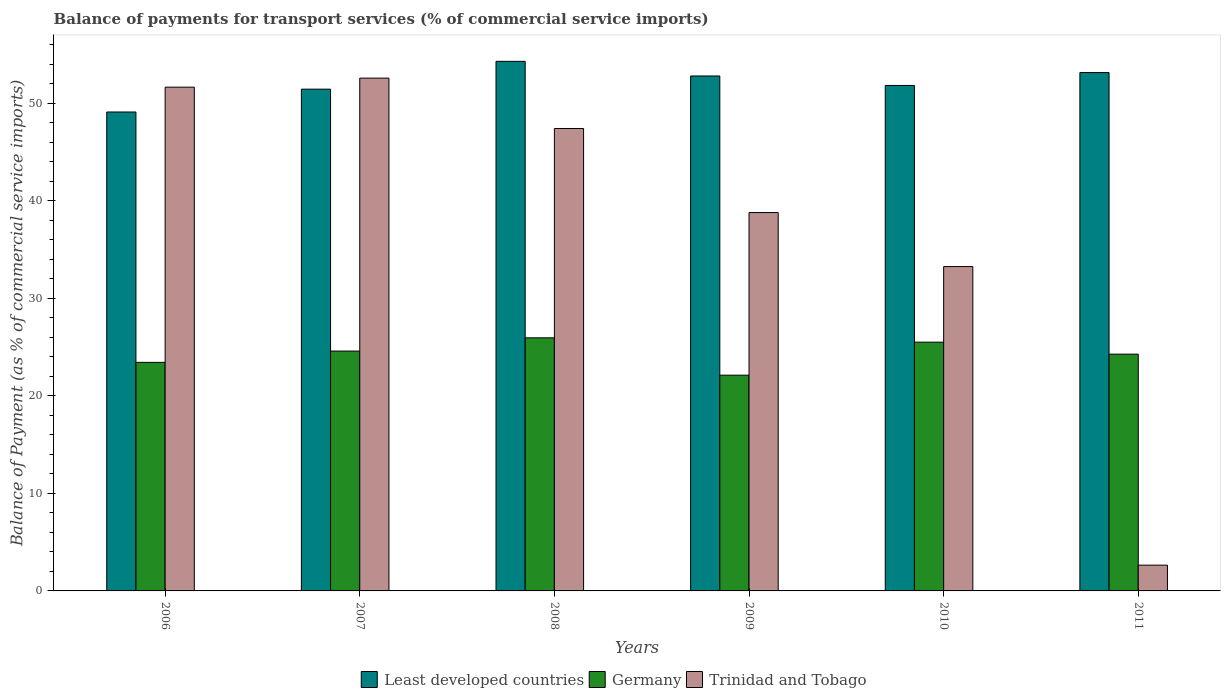How many different coloured bars are there?
Make the answer very short. 3. Are the number of bars per tick equal to the number of legend labels?
Offer a terse response. Yes. Are the number of bars on each tick of the X-axis equal?
Make the answer very short. Yes. What is the label of the 3rd group of bars from the left?
Offer a terse response. 2008. In how many cases, is the number of bars for a given year not equal to the number of legend labels?
Your answer should be compact. 0. What is the balance of payments for transport services in Least developed countries in 2010?
Ensure brevity in your answer.  51.83. Across all years, what is the maximum balance of payments for transport services in Trinidad and Tobago?
Offer a very short reply. 52.58. Across all years, what is the minimum balance of payments for transport services in Trinidad and Tobago?
Offer a terse response. 2.64. In which year was the balance of payments for transport services in Germany maximum?
Provide a short and direct response. 2008. What is the total balance of payments for transport services in Trinidad and Tobago in the graph?
Provide a succinct answer. 226.37. What is the difference between the balance of payments for transport services in Germany in 2009 and that in 2011?
Provide a succinct answer. -2.16. What is the difference between the balance of payments for transport services in Germany in 2008 and the balance of payments for transport services in Least developed countries in 2007?
Ensure brevity in your answer.  -25.5. What is the average balance of payments for transport services in Germany per year?
Keep it short and to the point. 24.32. In the year 2006, what is the difference between the balance of payments for transport services in Trinidad and Tobago and balance of payments for transport services in Least developed countries?
Provide a short and direct response. 2.54. In how many years, is the balance of payments for transport services in Least developed countries greater than 34 %?
Offer a very short reply. 6. What is the ratio of the balance of payments for transport services in Trinidad and Tobago in 2006 to that in 2007?
Offer a very short reply. 0.98. Is the balance of payments for transport services in Germany in 2007 less than that in 2011?
Offer a terse response. No. What is the difference between the highest and the second highest balance of payments for transport services in Germany?
Your answer should be very brief. 0.45. What is the difference between the highest and the lowest balance of payments for transport services in Germany?
Make the answer very short. 3.83. In how many years, is the balance of payments for transport services in Least developed countries greater than the average balance of payments for transport services in Least developed countries taken over all years?
Your answer should be very brief. 3. What does the 3rd bar from the left in 2010 represents?
Offer a terse response. Trinidad and Tobago. What does the 1st bar from the right in 2006 represents?
Offer a very short reply. Trinidad and Tobago. Is it the case that in every year, the sum of the balance of payments for transport services in Least developed countries and balance of payments for transport services in Trinidad and Tobago is greater than the balance of payments for transport services in Germany?
Provide a short and direct response. Yes. How many bars are there?
Offer a very short reply. 18. Are all the bars in the graph horizontal?
Your answer should be compact. No. How many years are there in the graph?
Your response must be concise. 6. Where does the legend appear in the graph?
Keep it short and to the point. Bottom center. What is the title of the graph?
Keep it short and to the point. Balance of payments for transport services (% of commercial service imports). Does "Gabon" appear as one of the legend labels in the graph?
Your answer should be compact. No. What is the label or title of the X-axis?
Your answer should be very brief. Years. What is the label or title of the Y-axis?
Your answer should be compact. Balance of Payment (as % of commercial service imports). What is the Balance of Payment (as % of commercial service imports) of Least developed countries in 2006?
Your answer should be very brief. 49.11. What is the Balance of Payment (as % of commercial service imports) of Germany in 2006?
Ensure brevity in your answer.  23.44. What is the Balance of Payment (as % of commercial service imports) of Trinidad and Tobago in 2006?
Make the answer very short. 51.66. What is the Balance of Payment (as % of commercial service imports) in Least developed countries in 2007?
Offer a terse response. 51.45. What is the Balance of Payment (as % of commercial service imports) in Germany in 2007?
Your answer should be very brief. 24.6. What is the Balance of Payment (as % of commercial service imports) in Trinidad and Tobago in 2007?
Make the answer very short. 52.58. What is the Balance of Payment (as % of commercial service imports) in Least developed countries in 2008?
Your response must be concise. 54.3. What is the Balance of Payment (as % of commercial service imports) in Germany in 2008?
Provide a succinct answer. 25.95. What is the Balance of Payment (as % of commercial service imports) of Trinidad and Tobago in 2008?
Your answer should be very brief. 47.42. What is the Balance of Payment (as % of commercial service imports) of Least developed countries in 2009?
Keep it short and to the point. 52.81. What is the Balance of Payment (as % of commercial service imports) of Germany in 2009?
Make the answer very short. 22.12. What is the Balance of Payment (as % of commercial service imports) in Trinidad and Tobago in 2009?
Your response must be concise. 38.8. What is the Balance of Payment (as % of commercial service imports) in Least developed countries in 2010?
Offer a very short reply. 51.83. What is the Balance of Payment (as % of commercial service imports) in Germany in 2010?
Ensure brevity in your answer.  25.51. What is the Balance of Payment (as % of commercial service imports) in Trinidad and Tobago in 2010?
Your response must be concise. 33.26. What is the Balance of Payment (as % of commercial service imports) in Least developed countries in 2011?
Your answer should be very brief. 53.15. What is the Balance of Payment (as % of commercial service imports) of Germany in 2011?
Keep it short and to the point. 24.28. What is the Balance of Payment (as % of commercial service imports) in Trinidad and Tobago in 2011?
Give a very brief answer. 2.64. Across all years, what is the maximum Balance of Payment (as % of commercial service imports) in Least developed countries?
Provide a short and direct response. 54.3. Across all years, what is the maximum Balance of Payment (as % of commercial service imports) in Germany?
Your response must be concise. 25.95. Across all years, what is the maximum Balance of Payment (as % of commercial service imports) of Trinidad and Tobago?
Provide a succinct answer. 52.58. Across all years, what is the minimum Balance of Payment (as % of commercial service imports) in Least developed countries?
Provide a short and direct response. 49.11. Across all years, what is the minimum Balance of Payment (as % of commercial service imports) of Germany?
Provide a short and direct response. 22.12. Across all years, what is the minimum Balance of Payment (as % of commercial service imports) in Trinidad and Tobago?
Give a very brief answer. 2.64. What is the total Balance of Payment (as % of commercial service imports) of Least developed countries in the graph?
Provide a succinct answer. 312.66. What is the total Balance of Payment (as % of commercial service imports) in Germany in the graph?
Offer a terse response. 145.9. What is the total Balance of Payment (as % of commercial service imports) of Trinidad and Tobago in the graph?
Ensure brevity in your answer.  226.37. What is the difference between the Balance of Payment (as % of commercial service imports) in Least developed countries in 2006 and that in 2007?
Keep it short and to the point. -2.34. What is the difference between the Balance of Payment (as % of commercial service imports) of Germany in 2006 and that in 2007?
Your answer should be very brief. -1.16. What is the difference between the Balance of Payment (as % of commercial service imports) in Trinidad and Tobago in 2006 and that in 2007?
Provide a succinct answer. -0.93. What is the difference between the Balance of Payment (as % of commercial service imports) of Least developed countries in 2006 and that in 2008?
Provide a short and direct response. -5.19. What is the difference between the Balance of Payment (as % of commercial service imports) in Germany in 2006 and that in 2008?
Your answer should be very brief. -2.52. What is the difference between the Balance of Payment (as % of commercial service imports) in Trinidad and Tobago in 2006 and that in 2008?
Your answer should be compact. 4.24. What is the difference between the Balance of Payment (as % of commercial service imports) of Least developed countries in 2006 and that in 2009?
Your answer should be compact. -3.69. What is the difference between the Balance of Payment (as % of commercial service imports) in Germany in 2006 and that in 2009?
Offer a very short reply. 1.31. What is the difference between the Balance of Payment (as % of commercial service imports) in Trinidad and Tobago in 2006 and that in 2009?
Offer a very short reply. 12.86. What is the difference between the Balance of Payment (as % of commercial service imports) in Least developed countries in 2006 and that in 2010?
Ensure brevity in your answer.  -2.72. What is the difference between the Balance of Payment (as % of commercial service imports) of Germany in 2006 and that in 2010?
Provide a succinct answer. -2.07. What is the difference between the Balance of Payment (as % of commercial service imports) in Trinidad and Tobago in 2006 and that in 2010?
Offer a terse response. 18.4. What is the difference between the Balance of Payment (as % of commercial service imports) in Least developed countries in 2006 and that in 2011?
Your answer should be compact. -4.04. What is the difference between the Balance of Payment (as % of commercial service imports) in Germany in 2006 and that in 2011?
Your response must be concise. -0.84. What is the difference between the Balance of Payment (as % of commercial service imports) of Trinidad and Tobago in 2006 and that in 2011?
Make the answer very short. 49.02. What is the difference between the Balance of Payment (as % of commercial service imports) of Least developed countries in 2007 and that in 2008?
Your response must be concise. -2.85. What is the difference between the Balance of Payment (as % of commercial service imports) in Germany in 2007 and that in 2008?
Your answer should be very brief. -1.36. What is the difference between the Balance of Payment (as % of commercial service imports) in Trinidad and Tobago in 2007 and that in 2008?
Ensure brevity in your answer.  5.16. What is the difference between the Balance of Payment (as % of commercial service imports) of Least developed countries in 2007 and that in 2009?
Your answer should be very brief. -1.35. What is the difference between the Balance of Payment (as % of commercial service imports) of Germany in 2007 and that in 2009?
Keep it short and to the point. 2.47. What is the difference between the Balance of Payment (as % of commercial service imports) of Trinidad and Tobago in 2007 and that in 2009?
Ensure brevity in your answer.  13.79. What is the difference between the Balance of Payment (as % of commercial service imports) of Least developed countries in 2007 and that in 2010?
Your answer should be compact. -0.38. What is the difference between the Balance of Payment (as % of commercial service imports) in Germany in 2007 and that in 2010?
Give a very brief answer. -0.91. What is the difference between the Balance of Payment (as % of commercial service imports) of Trinidad and Tobago in 2007 and that in 2010?
Provide a short and direct response. 19.32. What is the difference between the Balance of Payment (as % of commercial service imports) of Least developed countries in 2007 and that in 2011?
Keep it short and to the point. -1.7. What is the difference between the Balance of Payment (as % of commercial service imports) of Germany in 2007 and that in 2011?
Make the answer very short. 0.32. What is the difference between the Balance of Payment (as % of commercial service imports) of Trinidad and Tobago in 2007 and that in 2011?
Give a very brief answer. 49.94. What is the difference between the Balance of Payment (as % of commercial service imports) of Least developed countries in 2008 and that in 2009?
Ensure brevity in your answer.  1.5. What is the difference between the Balance of Payment (as % of commercial service imports) of Germany in 2008 and that in 2009?
Give a very brief answer. 3.83. What is the difference between the Balance of Payment (as % of commercial service imports) of Trinidad and Tobago in 2008 and that in 2009?
Provide a short and direct response. 8.62. What is the difference between the Balance of Payment (as % of commercial service imports) in Least developed countries in 2008 and that in 2010?
Your answer should be very brief. 2.47. What is the difference between the Balance of Payment (as % of commercial service imports) of Germany in 2008 and that in 2010?
Offer a very short reply. 0.45. What is the difference between the Balance of Payment (as % of commercial service imports) of Trinidad and Tobago in 2008 and that in 2010?
Make the answer very short. 14.16. What is the difference between the Balance of Payment (as % of commercial service imports) in Least developed countries in 2008 and that in 2011?
Your answer should be very brief. 1.15. What is the difference between the Balance of Payment (as % of commercial service imports) in Germany in 2008 and that in 2011?
Ensure brevity in your answer.  1.67. What is the difference between the Balance of Payment (as % of commercial service imports) in Trinidad and Tobago in 2008 and that in 2011?
Your answer should be very brief. 44.78. What is the difference between the Balance of Payment (as % of commercial service imports) of Least developed countries in 2009 and that in 2010?
Offer a terse response. 0.97. What is the difference between the Balance of Payment (as % of commercial service imports) of Germany in 2009 and that in 2010?
Offer a very short reply. -3.38. What is the difference between the Balance of Payment (as % of commercial service imports) in Trinidad and Tobago in 2009 and that in 2010?
Keep it short and to the point. 5.54. What is the difference between the Balance of Payment (as % of commercial service imports) in Least developed countries in 2009 and that in 2011?
Ensure brevity in your answer.  -0.35. What is the difference between the Balance of Payment (as % of commercial service imports) of Germany in 2009 and that in 2011?
Keep it short and to the point. -2.16. What is the difference between the Balance of Payment (as % of commercial service imports) in Trinidad and Tobago in 2009 and that in 2011?
Give a very brief answer. 36.16. What is the difference between the Balance of Payment (as % of commercial service imports) in Least developed countries in 2010 and that in 2011?
Your answer should be compact. -1.32. What is the difference between the Balance of Payment (as % of commercial service imports) of Germany in 2010 and that in 2011?
Offer a terse response. 1.23. What is the difference between the Balance of Payment (as % of commercial service imports) of Trinidad and Tobago in 2010 and that in 2011?
Offer a very short reply. 30.62. What is the difference between the Balance of Payment (as % of commercial service imports) in Least developed countries in 2006 and the Balance of Payment (as % of commercial service imports) in Germany in 2007?
Offer a terse response. 24.52. What is the difference between the Balance of Payment (as % of commercial service imports) of Least developed countries in 2006 and the Balance of Payment (as % of commercial service imports) of Trinidad and Tobago in 2007?
Give a very brief answer. -3.47. What is the difference between the Balance of Payment (as % of commercial service imports) of Germany in 2006 and the Balance of Payment (as % of commercial service imports) of Trinidad and Tobago in 2007?
Provide a succinct answer. -29.15. What is the difference between the Balance of Payment (as % of commercial service imports) of Least developed countries in 2006 and the Balance of Payment (as % of commercial service imports) of Germany in 2008?
Your response must be concise. 23.16. What is the difference between the Balance of Payment (as % of commercial service imports) in Least developed countries in 2006 and the Balance of Payment (as % of commercial service imports) in Trinidad and Tobago in 2008?
Provide a short and direct response. 1.69. What is the difference between the Balance of Payment (as % of commercial service imports) in Germany in 2006 and the Balance of Payment (as % of commercial service imports) in Trinidad and Tobago in 2008?
Make the answer very short. -23.98. What is the difference between the Balance of Payment (as % of commercial service imports) in Least developed countries in 2006 and the Balance of Payment (as % of commercial service imports) in Germany in 2009?
Your answer should be compact. 26.99. What is the difference between the Balance of Payment (as % of commercial service imports) in Least developed countries in 2006 and the Balance of Payment (as % of commercial service imports) in Trinidad and Tobago in 2009?
Offer a terse response. 10.31. What is the difference between the Balance of Payment (as % of commercial service imports) in Germany in 2006 and the Balance of Payment (as % of commercial service imports) in Trinidad and Tobago in 2009?
Your response must be concise. -15.36. What is the difference between the Balance of Payment (as % of commercial service imports) in Least developed countries in 2006 and the Balance of Payment (as % of commercial service imports) in Germany in 2010?
Your answer should be compact. 23.6. What is the difference between the Balance of Payment (as % of commercial service imports) in Least developed countries in 2006 and the Balance of Payment (as % of commercial service imports) in Trinidad and Tobago in 2010?
Your response must be concise. 15.85. What is the difference between the Balance of Payment (as % of commercial service imports) in Germany in 2006 and the Balance of Payment (as % of commercial service imports) in Trinidad and Tobago in 2010?
Make the answer very short. -9.82. What is the difference between the Balance of Payment (as % of commercial service imports) of Least developed countries in 2006 and the Balance of Payment (as % of commercial service imports) of Germany in 2011?
Provide a succinct answer. 24.83. What is the difference between the Balance of Payment (as % of commercial service imports) of Least developed countries in 2006 and the Balance of Payment (as % of commercial service imports) of Trinidad and Tobago in 2011?
Ensure brevity in your answer.  46.47. What is the difference between the Balance of Payment (as % of commercial service imports) of Germany in 2006 and the Balance of Payment (as % of commercial service imports) of Trinidad and Tobago in 2011?
Keep it short and to the point. 20.79. What is the difference between the Balance of Payment (as % of commercial service imports) in Least developed countries in 2007 and the Balance of Payment (as % of commercial service imports) in Germany in 2008?
Offer a very short reply. 25.5. What is the difference between the Balance of Payment (as % of commercial service imports) in Least developed countries in 2007 and the Balance of Payment (as % of commercial service imports) in Trinidad and Tobago in 2008?
Offer a terse response. 4.03. What is the difference between the Balance of Payment (as % of commercial service imports) in Germany in 2007 and the Balance of Payment (as % of commercial service imports) in Trinidad and Tobago in 2008?
Keep it short and to the point. -22.82. What is the difference between the Balance of Payment (as % of commercial service imports) of Least developed countries in 2007 and the Balance of Payment (as % of commercial service imports) of Germany in 2009?
Your answer should be very brief. 29.33. What is the difference between the Balance of Payment (as % of commercial service imports) in Least developed countries in 2007 and the Balance of Payment (as % of commercial service imports) in Trinidad and Tobago in 2009?
Give a very brief answer. 12.65. What is the difference between the Balance of Payment (as % of commercial service imports) of Germany in 2007 and the Balance of Payment (as % of commercial service imports) of Trinidad and Tobago in 2009?
Provide a succinct answer. -14.2. What is the difference between the Balance of Payment (as % of commercial service imports) in Least developed countries in 2007 and the Balance of Payment (as % of commercial service imports) in Germany in 2010?
Keep it short and to the point. 25.94. What is the difference between the Balance of Payment (as % of commercial service imports) in Least developed countries in 2007 and the Balance of Payment (as % of commercial service imports) in Trinidad and Tobago in 2010?
Provide a succinct answer. 18.19. What is the difference between the Balance of Payment (as % of commercial service imports) of Germany in 2007 and the Balance of Payment (as % of commercial service imports) of Trinidad and Tobago in 2010?
Ensure brevity in your answer.  -8.67. What is the difference between the Balance of Payment (as % of commercial service imports) of Least developed countries in 2007 and the Balance of Payment (as % of commercial service imports) of Germany in 2011?
Make the answer very short. 27.17. What is the difference between the Balance of Payment (as % of commercial service imports) of Least developed countries in 2007 and the Balance of Payment (as % of commercial service imports) of Trinidad and Tobago in 2011?
Your response must be concise. 48.81. What is the difference between the Balance of Payment (as % of commercial service imports) in Germany in 2007 and the Balance of Payment (as % of commercial service imports) in Trinidad and Tobago in 2011?
Make the answer very short. 21.95. What is the difference between the Balance of Payment (as % of commercial service imports) of Least developed countries in 2008 and the Balance of Payment (as % of commercial service imports) of Germany in 2009?
Provide a short and direct response. 32.18. What is the difference between the Balance of Payment (as % of commercial service imports) in Least developed countries in 2008 and the Balance of Payment (as % of commercial service imports) in Trinidad and Tobago in 2009?
Make the answer very short. 15.51. What is the difference between the Balance of Payment (as % of commercial service imports) of Germany in 2008 and the Balance of Payment (as % of commercial service imports) of Trinidad and Tobago in 2009?
Your response must be concise. -12.84. What is the difference between the Balance of Payment (as % of commercial service imports) of Least developed countries in 2008 and the Balance of Payment (as % of commercial service imports) of Germany in 2010?
Ensure brevity in your answer.  28.8. What is the difference between the Balance of Payment (as % of commercial service imports) in Least developed countries in 2008 and the Balance of Payment (as % of commercial service imports) in Trinidad and Tobago in 2010?
Ensure brevity in your answer.  21.04. What is the difference between the Balance of Payment (as % of commercial service imports) in Germany in 2008 and the Balance of Payment (as % of commercial service imports) in Trinidad and Tobago in 2010?
Your response must be concise. -7.31. What is the difference between the Balance of Payment (as % of commercial service imports) of Least developed countries in 2008 and the Balance of Payment (as % of commercial service imports) of Germany in 2011?
Your answer should be compact. 30.03. What is the difference between the Balance of Payment (as % of commercial service imports) in Least developed countries in 2008 and the Balance of Payment (as % of commercial service imports) in Trinidad and Tobago in 2011?
Make the answer very short. 51.66. What is the difference between the Balance of Payment (as % of commercial service imports) of Germany in 2008 and the Balance of Payment (as % of commercial service imports) of Trinidad and Tobago in 2011?
Make the answer very short. 23.31. What is the difference between the Balance of Payment (as % of commercial service imports) of Least developed countries in 2009 and the Balance of Payment (as % of commercial service imports) of Germany in 2010?
Keep it short and to the point. 27.3. What is the difference between the Balance of Payment (as % of commercial service imports) of Least developed countries in 2009 and the Balance of Payment (as % of commercial service imports) of Trinidad and Tobago in 2010?
Provide a succinct answer. 19.54. What is the difference between the Balance of Payment (as % of commercial service imports) of Germany in 2009 and the Balance of Payment (as % of commercial service imports) of Trinidad and Tobago in 2010?
Keep it short and to the point. -11.14. What is the difference between the Balance of Payment (as % of commercial service imports) in Least developed countries in 2009 and the Balance of Payment (as % of commercial service imports) in Germany in 2011?
Provide a succinct answer. 28.53. What is the difference between the Balance of Payment (as % of commercial service imports) in Least developed countries in 2009 and the Balance of Payment (as % of commercial service imports) in Trinidad and Tobago in 2011?
Give a very brief answer. 50.16. What is the difference between the Balance of Payment (as % of commercial service imports) in Germany in 2009 and the Balance of Payment (as % of commercial service imports) in Trinidad and Tobago in 2011?
Provide a succinct answer. 19.48. What is the difference between the Balance of Payment (as % of commercial service imports) in Least developed countries in 2010 and the Balance of Payment (as % of commercial service imports) in Germany in 2011?
Give a very brief answer. 27.55. What is the difference between the Balance of Payment (as % of commercial service imports) in Least developed countries in 2010 and the Balance of Payment (as % of commercial service imports) in Trinidad and Tobago in 2011?
Give a very brief answer. 49.19. What is the difference between the Balance of Payment (as % of commercial service imports) in Germany in 2010 and the Balance of Payment (as % of commercial service imports) in Trinidad and Tobago in 2011?
Your answer should be very brief. 22.87. What is the average Balance of Payment (as % of commercial service imports) of Least developed countries per year?
Your answer should be compact. 52.11. What is the average Balance of Payment (as % of commercial service imports) of Germany per year?
Provide a short and direct response. 24.32. What is the average Balance of Payment (as % of commercial service imports) of Trinidad and Tobago per year?
Ensure brevity in your answer.  37.73. In the year 2006, what is the difference between the Balance of Payment (as % of commercial service imports) of Least developed countries and Balance of Payment (as % of commercial service imports) of Germany?
Offer a very short reply. 25.68. In the year 2006, what is the difference between the Balance of Payment (as % of commercial service imports) of Least developed countries and Balance of Payment (as % of commercial service imports) of Trinidad and Tobago?
Make the answer very short. -2.54. In the year 2006, what is the difference between the Balance of Payment (as % of commercial service imports) of Germany and Balance of Payment (as % of commercial service imports) of Trinidad and Tobago?
Your response must be concise. -28.22. In the year 2007, what is the difference between the Balance of Payment (as % of commercial service imports) of Least developed countries and Balance of Payment (as % of commercial service imports) of Germany?
Offer a terse response. 26.86. In the year 2007, what is the difference between the Balance of Payment (as % of commercial service imports) of Least developed countries and Balance of Payment (as % of commercial service imports) of Trinidad and Tobago?
Ensure brevity in your answer.  -1.13. In the year 2007, what is the difference between the Balance of Payment (as % of commercial service imports) in Germany and Balance of Payment (as % of commercial service imports) in Trinidad and Tobago?
Ensure brevity in your answer.  -27.99. In the year 2008, what is the difference between the Balance of Payment (as % of commercial service imports) in Least developed countries and Balance of Payment (as % of commercial service imports) in Germany?
Provide a short and direct response. 28.35. In the year 2008, what is the difference between the Balance of Payment (as % of commercial service imports) of Least developed countries and Balance of Payment (as % of commercial service imports) of Trinidad and Tobago?
Make the answer very short. 6.88. In the year 2008, what is the difference between the Balance of Payment (as % of commercial service imports) in Germany and Balance of Payment (as % of commercial service imports) in Trinidad and Tobago?
Give a very brief answer. -21.47. In the year 2009, what is the difference between the Balance of Payment (as % of commercial service imports) in Least developed countries and Balance of Payment (as % of commercial service imports) in Germany?
Your answer should be very brief. 30.68. In the year 2009, what is the difference between the Balance of Payment (as % of commercial service imports) of Least developed countries and Balance of Payment (as % of commercial service imports) of Trinidad and Tobago?
Give a very brief answer. 14.01. In the year 2009, what is the difference between the Balance of Payment (as % of commercial service imports) in Germany and Balance of Payment (as % of commercial service imports) in Trinidad and Tobago?
Provide a short and direct response. -16.68. In the year 2010, what is the difference between the Balance of Payment (as % of commercial service imports) of Least developed countries and Balance of Payment (as % of commercial service imports) of Germany?
Offer a very short reply. 26.32. In the year 2010, what is the difference between the Balance of Payment (as % of commercial service imports) of Least developed countries and Balance of Payment (as % of commercial service imports) of Trinidad and Tobago?
Offer a very short reply. 18.57. In the year 2010, what is the difference between the Balance of Payment (as % of commercial service imports) of Germany and Balance of Payment (as % of commercial service imports) of Trinidad and Tobago?
Offer a terse response. -7.75. In the year 2011, what is the difference between the Balance of Payment (as % of commercial service imports) of Least developed countries and Balance of Payment (as % of commercial service imports) of Germany?
Give a very brief answer. 28.87. In the year 2011, what is the difference between the Balance of Payment (as % of commercial service imports) in Least developed countries and Balance of Payment (as % of commercial service imports) in Trinidad and Tobago?
Your answer should be very brief. 50.51. In the year 2011, what is the difference between the Balance of Payment (as % of commercial service imports) in Germany and Balance of Payment (as % of commercial service imports) in Trinidad and Tobago?
Make the answer very short. 21.64. What is the ratio of the Balance of Payment (as % of commercial service imports) in Least developed countries in 2006 to that in 2007?
Provide a succinct answer. 0.95. What is the ratio of the Balance of Payment (as % of commercial service imports) in Germany in 2006 to that in 2007?
Your answer should be very brief. 0.95. What is the ratio of the Balance of Payment (as % of commercial service imports) in Trinidad and Tobago in 2006 to that in 2007?
Your answer should be compact. 0.98. What is the ratio of the Balance of Payment (as % of commercial service imports) in Least developed countries in 2006 to that in 2008?
Your response must be concise. 0.9. What is the ratio of the Balance of Payment (as % of commercial service imports) of Germany in 2006 to that in 2008?
Keep it short and to the point. 0.9. What is the ratio of the Balance of Payment (as % of commercial service imports) of Trinidad and Tobago in 2006 to that in 2008?
Provide a succinct answer. 1.09. What is the ratio of the Balance of Payment (as % of commercial service imports) in Least developed countries in 2006 to that in 2009?
Ensure brevity in your answer.  0.93. What is the ratio of the Balance of Payment (as % of commercial service imports) of Germany in 2006 to that in 2009?
Provide a short and direct response. 1.06. What is the ratio of the Balance of Payment (as % of commercial service imports) of Trinidad and Tobago in 2006 to that in 2009?
Provide a succinct answer. 1.33. What is the ratio of the Balance of Payment (as % of commercial service imports) in Least developed countries in 2006 to that in 2010?
Offer a terse response. 0.95. What is the ratio of the Balance of Payment (as % of commercial service imports) in Germany in 2006 to that in 2010?
Your response must be concise. 0.92. What is the ratio of the Balance of Payment (as % of commercial service imports) in Trinidad and Tobago in 2006 to that in 2010?
Keep it short and to the point. 1.55. What is the ratio of the Balance of Payment (as % of commercial service imports) of Least developed countries in 2006 to that in 2011?
Offer a very short reply. 0.92. What is the ratio of the Balance of Payment (as % of commercial service imports) in Germany in 2006 to that in 2011?
Make the answer very short. 0.97. What is the ratio of the Balance of Payment (as % of commercial service imports) in Trinidad and Tobago in 2006 to that in 2011?
Provide a short and direct response. 19.55. What is the ratio of the Balance of Payment (as % of commercial service imports) in Least developed countries in 2007 to that in 2008?
Give a very brief answer. 0.95. What is the ratio of the Balance of Payment (as % of commercial service imports) in Germany in 2007 to that in 2008?
Your answer should be compact. 0.95. What is the ratio of the Balance of Payment (as % of commercial service imports) in Trinidad and Tobago in 2007 to that in 2008?
Your response must be concise. 1.11. What is the ratio of the Balance of Payment (as % of commercial service imports) of Least developed countries in 2007 to that in 2009?
Your answer should be compact. 0.97. What is the ratio of the Balance of Payment (as % of commercial service imports) of Germany in 2007 to that in 2009?
Your response must be concise. 1.11. What is the ratio of the Balance of Payment (as % of commercial service imports) in Trinidad and Tobago in 2007 to that in 2009?
Offer a very short reply. 1.36. What is the ratio of the Balance of Payment (as % of commercial service imports) of Least developed countries in 2007 to that in 2010?
Provide a short and direct response. 0.99. What is the ratio of the Balance of Payment (as % of commercial service imports) of Germany in 2007 to that in 2010?
Your response must be concise. 0.96. What is the ratio of the Balance of Payment (as % of commercial service imports) of Trinidad and Tobago in 2007 to that in 2010?
Offer a very short reply. 1.58. What is the ratio of the Balance of Payment (as % of commercial service imports) in Least developed countries in 2007 to that in 2011?
Your answer should be compact. 0.97. What is the ratio of the Balance of Payment (as % of commercial service imports) in Germany in 2007 to that in 2011?
Provide a succinct answer. 1.01. What is the ratio of the Balance of Payment (as % of commercial service imports) in Trinidad and Tobago in 2007 to that in 2011?
Give a very brief answer. 19.9. What is the ratio of the Balance of Payment (as % of commercial service imports) of Least developed countries in 2008 to that in 2009?
Your response must be concise. 1.03. What is the ratio of the Balance of Payment (as % of commercial service imports) of Germany in 2008 to that in 2009?
Your answer should be very brief. 1.17. What is the ratio of the Balance of Payment (as % of commercial service imports) in Trinidad and Tobago in 2008 to that in 2009?
Your answer should be very brief. 1.22. What is the ratio of the Balance of Payment (as % of commercial service imports) of Least developed countries in 2008 to that in 2010?
Keep it short and to the point. 1.05. What is the ratio of the Balance of Payment (as % of commercial service imports) of Germany in 2008 to that in 2010?
Ensure brevity in your answer.  1.02. What is the ratio of the Balance of Payment (as % of commercial service imports) of Trinidad and Tobago in 2008 to that in 2010?
Provide a short and direct response. 1.43. What is the ratio of the Balance of Payment (as % of commercial service imports) in Least developed countries in 2008 to that in 2011?
Provide a short and direct response. 1.02. What is the ratio of the Balance of Payment (as % of commercial service imports) of Germany in 2008 to that in 2011?
Keep it short and to the point. 1.07. What is the ratio of the Balance of Payment (as % of commercial service imports) of Trinidad and Tobago in 2008 to that in 2011?
Offer a very short reply. 17.95. What is the ratio of the Balance of Payment (as % of commercial service imports) in Least developed countries in 2009 to that in 2010?
Make the answer very short. 1.02. What is the ratio of the Balance of Payment (as % of commercial service imports) in Germany in 2009 to that in 2010?
Provide a succinct answer. 0.87. What is the ratio of the Balance of Payment (as % of commercial service imports) of Trinidad and Tobago in 2009 to that in 2010?
Your answer should be compact. 1.17. What is the ratio of the Balance of Payment (as % of commercial service imports) in Least developed countries in 2009 to that in 2011?
Make the answer very short. 0.99. What is the ratio of the Balance of Payment (as % of commercial service imports) in Germany in 2009 to that in 2011?
Your answer should be very brief. 0.91. What is the ratio of the Balance of Payment (as % of commercial service imports) of Trinidad and Tobago in 2009 to that in 2011?
Provide a short and direct response. 14.68. What is the ratio of the Balance of Payment (as % of commercial service imports) of Least developed countries in 2010 to that in 2011?
Make the answer very short. 0.98. What is the ratio of the Balance of Payment (as % of commercial service imports) of Germany in 2010 to that in 2011?
Provide a short and direct response. 1.05. What is the ratio of the Balance of Payment (as % of commercial service imports) in Trinidad and Tobago in 2010 to that in 2011?
Ensure brevity in your answer.  12.59. What is the difference between the highest and the second highest Balance of Payment (as % of commercial service imports) of Least developed countries?
Make the answer very short. 1.15. What is the difference between the highest and the second highest Balance of Payment (as % of commercial service imports) in Germany?
Your answer should be compact. 0.45. What is the difference between the highest and the second highest Balance of Payment (as % of commercial service imports) in Trinidad and Tobago?
Keep it short and to the point. 0.93. What is the difference between the highest and the lowest Balance of Payment (as % of commercial service imports) of Least developed countries?
Ensure brevity in your answer.  5.19. What is the difference between the highest and the lowest Balance of Payment (as % of commercial service imports) in Germany?
Provide a succinct answer. 3.83. What is the difference between the highest and the lowest Balance of Payment (as % of commercial service imports) of Trinidad and Tobago?
Make the answer very short. 49.94. 